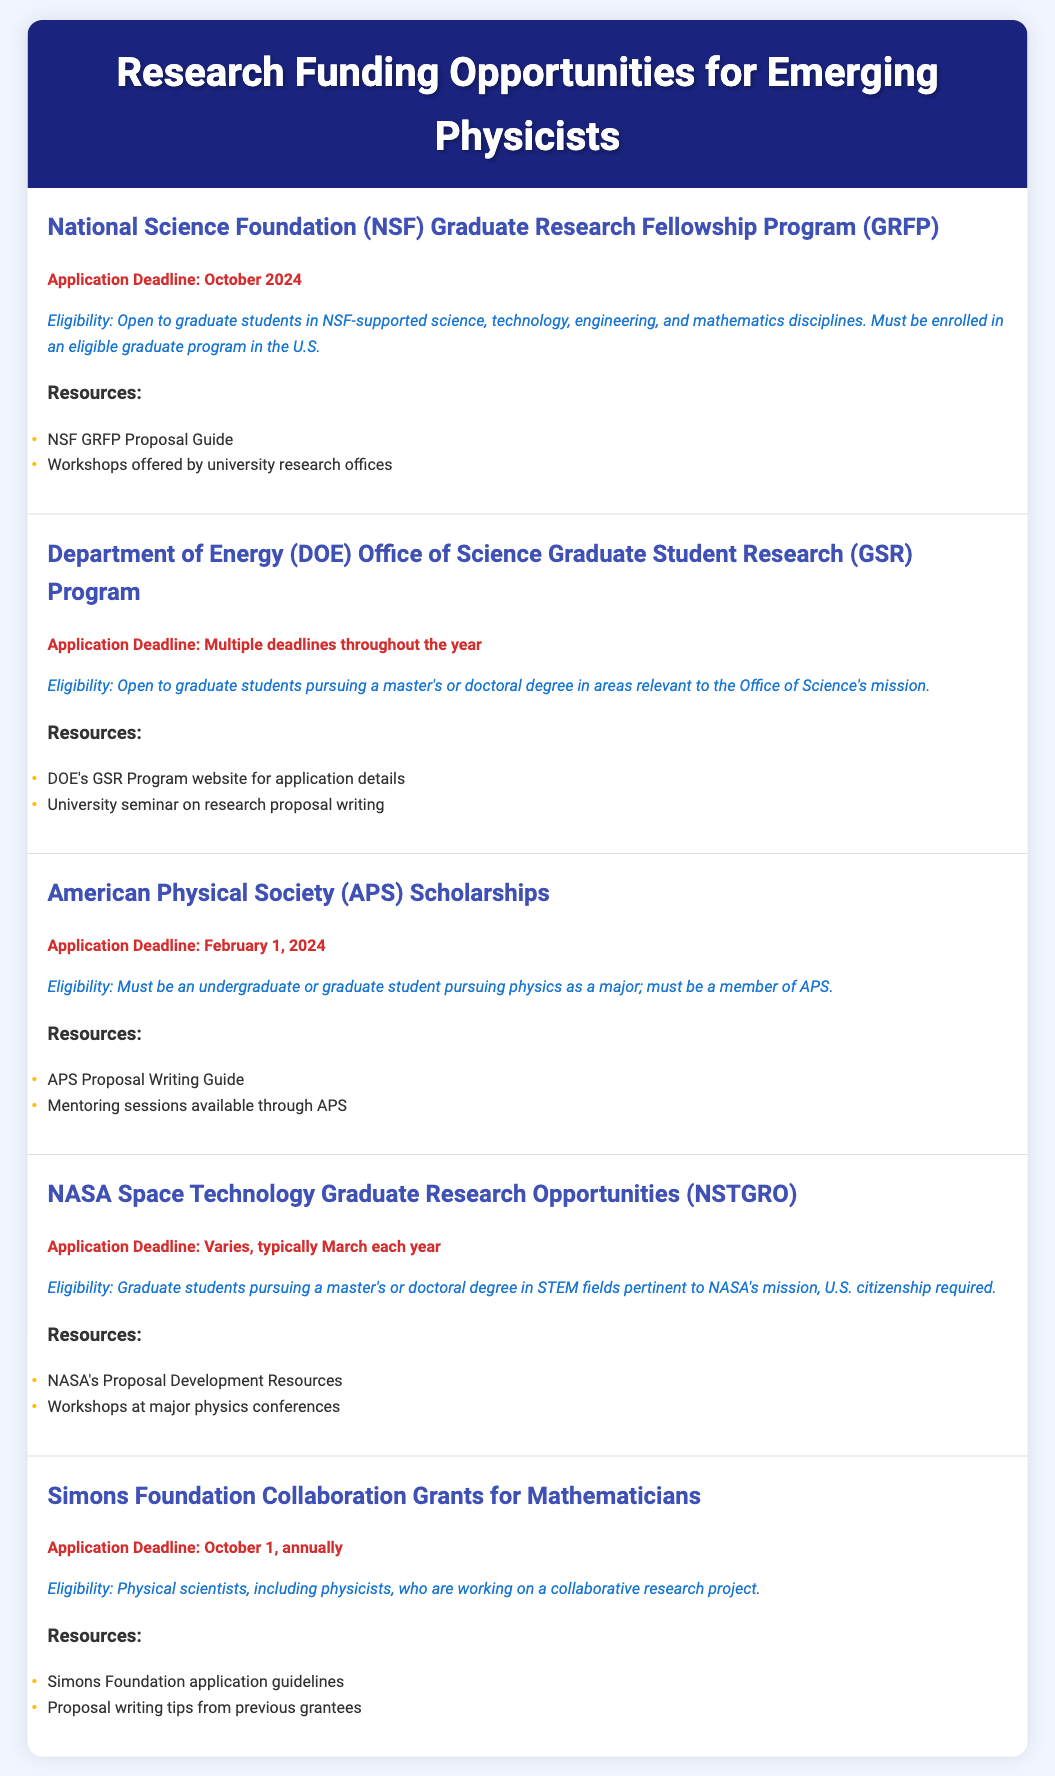What is the application deadline for the NSF GRFP? The application deadline for the NSF GRFP is specified in the document as October 2024.
Answer: October 2024 What is the eligibility requirement for the APS Scholarships? The document states that eligibility for APS Scholarships requires students to be pursuing physics as a major and be a member of APS.
Answer: Must be a member of APS When is the application deadline for the Simons Foundation grants? According to the document, the application deadline for the Simons Foundation grants is annually on October 1.
Answer: October 1, annually Which funding opportunity has multiple deadlines throughout the year? The document indicates that the DOE Office of Science Graduate Student Research Program has multiple deadlines throughout the year.
Answer: DOE Office of Science Graduate Student Research Program What resources are available for writing proposals for NASA NSTGRO? The document lists NASA's Proposal Development Resources and workshops at major physics conferences as resources for proposal writing for NSTGRO.
Answer: NASA's Proposal Development Resources, workshops at major physics conferences What type of graduate students are eligible for the NASA NSTGRO? The document specifies that graduate students pursuing a master's or doctoral degree in STEM fields pertinent to NASA's mission are eligible.
Answer: Graduate students in STEM fields 